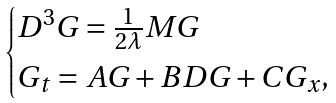Convert formula to latex. <formula><loc_0><loc_0><loc_500><loc_500>\begin{cases} D ^ { 3 } G = \frac { 1 } { 2 \lambda } M G \\ G _ { t } = A G + B D G + C G _ { x } , \end{cases}</formula> 